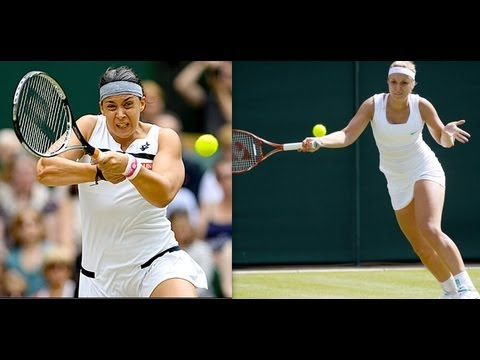Please identify all text content in this image. P 